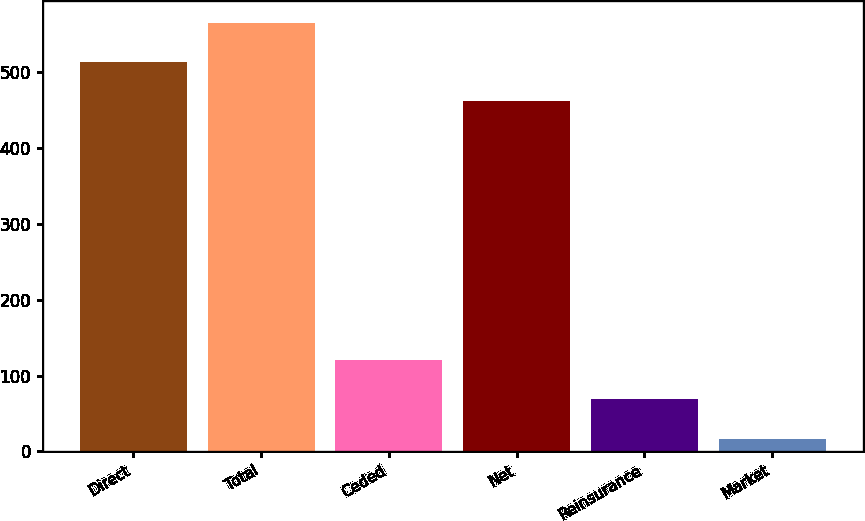<chart> <loc_0><loc_0><loc_500><loc_500><bar_chart><fcel>Direct<fcel>Total<fcel>Ceded<fcel>Net<fcel>Reinsurance<fcel>Market<nl><fcel>513.8<fcel>565.6<fcel>120.6<fcel>462<fcel>68.8<fcel>17<nl></chart> 